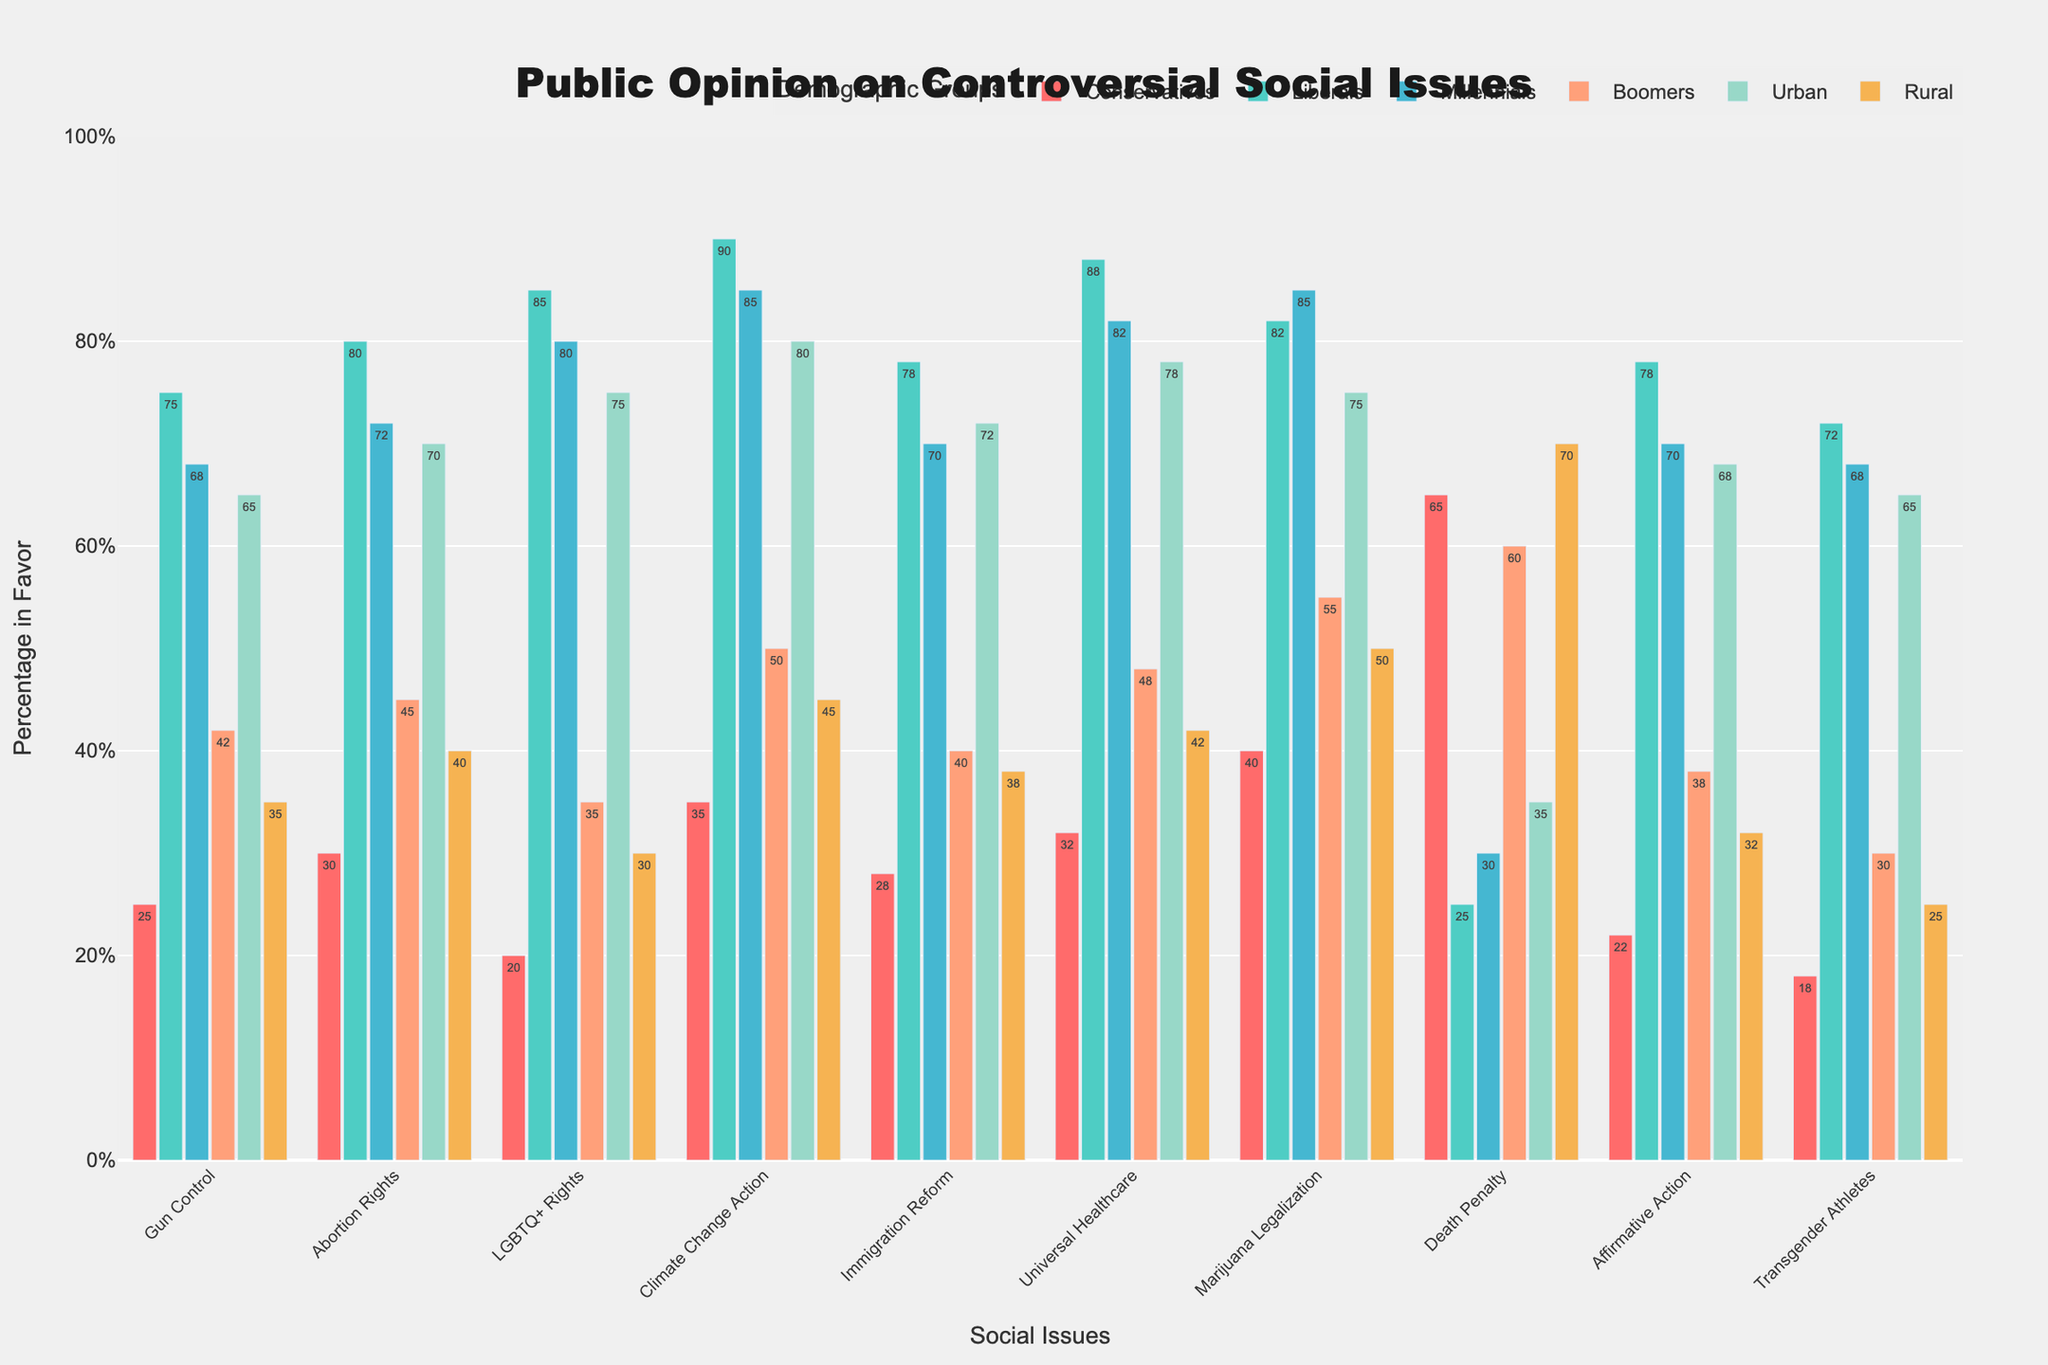How does support for gun control differ between conservatives and liberals? To find the difference in support for gun control between conservatives and liberals, subtract the percentage of conservatives in favor from the percentage of liberals in favor: 75% (liberals) - 25% (conservatives) = 50%.
Answer: 50% Which demographic group shows the highest support for immigration reform? By comparing the percentages of support for immigration reform across all demographic groups, we see that liberals show the highest support at 78%.
Answer: Liberals What is the average support for abortion rights among Millennials and Boomers? To find the average support for abortion rights among Millennials and Boomers, add their respective percentages and divide by 2: (72% + 45%) / 2 = 58.5%.
Answer: 58.5% Which issue shows the largest disagreement between urban and rural populations? By calculating the absolute differences for each issue between urban and rural populations, the largest gap is found in LGBTQ+ Rights: 75% (urban) - 30% (rural) = 45%.
Answer: LGBTQ+ Rights Do Millennials or Boomers show higher support for climate change action? By comparing their percentages directly, Millennials show higher support for climate change action with 85%, compared to Boomers' 50%.
Answer: Millennials What is the combined average support for universal healthcare among conservatives, liberals, and Urban populations? First, add the percentages of support among conservatives, liberals, and Urban populations: 32% (conservatives) + 88% (liberals) + 78% (Urban) = 198%. Then, divide by the number of groups: 198% / 3 = 66%.
Answer: 66% How does support for the death penalty among rural populations compare to urban populations? Compare the respective percentages of support: Rural (70%) and Urban (35%). Rural populations show double the support at 35% higher.
Answer: Rural, 35% higher Which group shows the lowest support for transgender athletes participating in sports? By scanning the percentages for all demographic groups, conservatives show the lowest support at 18%.
Answer: Conservatives What is the difference in support for marijuana legalization between the most and least supportive demographic groups? Liberals show the highest support at 82%, and conservatives the lowest at 40%. The difference is 82% - 40% = 42%.
Answer: 42% Which demographic groups have more than 50% support across all issues? By examining all percentages, only liberals and Millennials consistently show more than 50% support across all issues.
Answer: Liberals, Millennials 